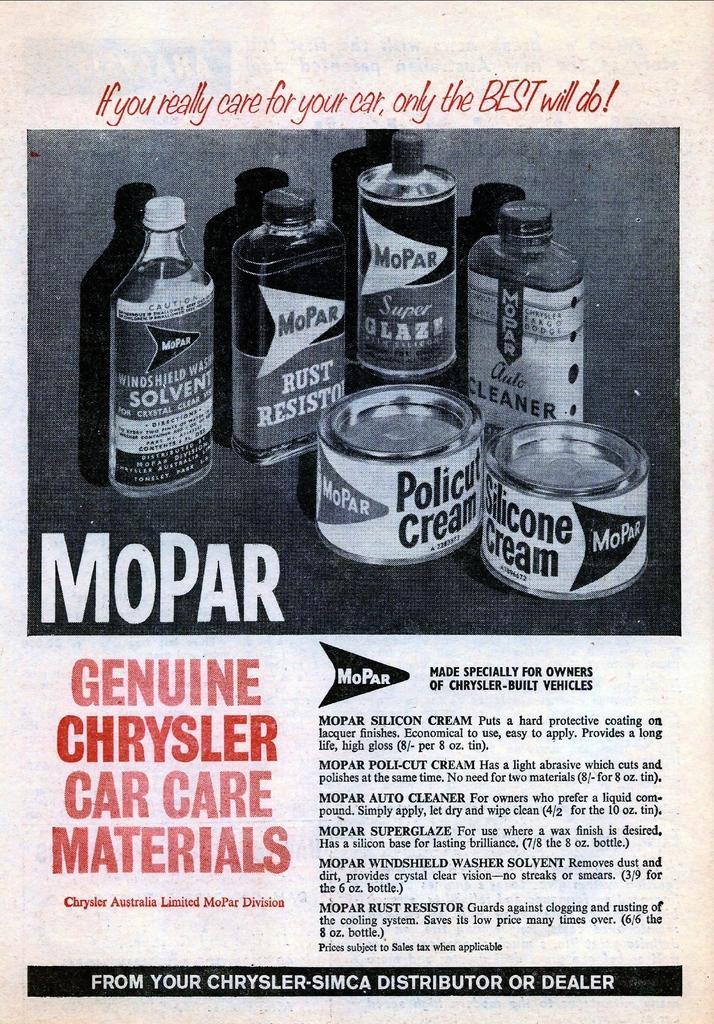Could you give a brief overview of what you see in this image? In the center of the image we can see one poster. On the poster, we can see bottles, round shape boxes, some text and a few other objects. And we can see some text on the bottles and on the round shape objects. 